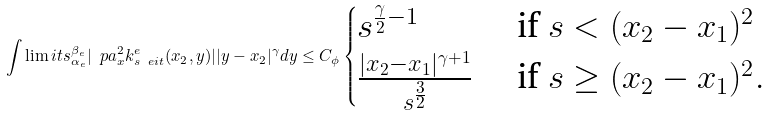<formula> <loc_0><loc_0><loc_500><loc_500>\int \lim i t s _ { \alpha _ { e } } ^ { \beta _ { e } } | \ p a _ { x } ^ { 2 } k ^ { e } _ { s \ e i t } ( x _ { 2 } , y ) | | y - x _ { 2 } | ^ { \gamma } d y \leq C _ { \phi } \begin{cases} s ^ { \frac { \gamma } { 2 } - 1 } & \text { if } s < ( x _ { 2 } - x _ { 1 } ) ^ { 2 } \\ \frac { | x _ { 2 } - x _ { 1 } | ^ { \gamma + 1 } } { s ^ { \frac { 3 } { 2 } } } & \text { if } s \geq ( x _ { 2 } - x _ { 1 } ) ^ { 2 } . \end{cases}</formula> 